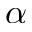<formula> <loc_0><loc_0><loc_500><loc_500>\alpha</formula> 